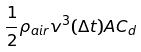<formula> <loc_0><loc_0><loc_500><loc_500>\frac { 1 } { 2 } \rho _ { a i r } v ^ { 3 } ( \Delta t ) A C _ { d }</formula> 